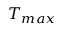<formula> <loc_0><loc_0><loc_500><loc_500>T _ { \max }</formula> 